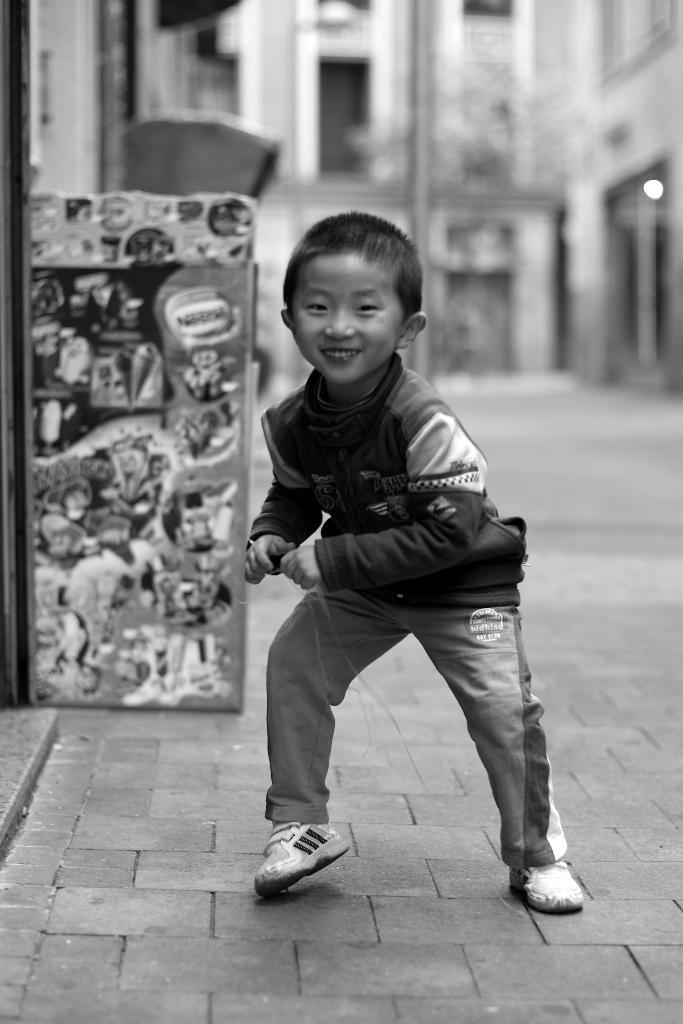What is the color scheme of the image? The image is black and white. What is the main subject in the image? There is a kid standing on the ground in the middle of the image. What can be seen in the background of the image? There is a building in the background of the image. What book is the kid reading in the image? There is no book visible in the image, and the kid is not shown reading. 